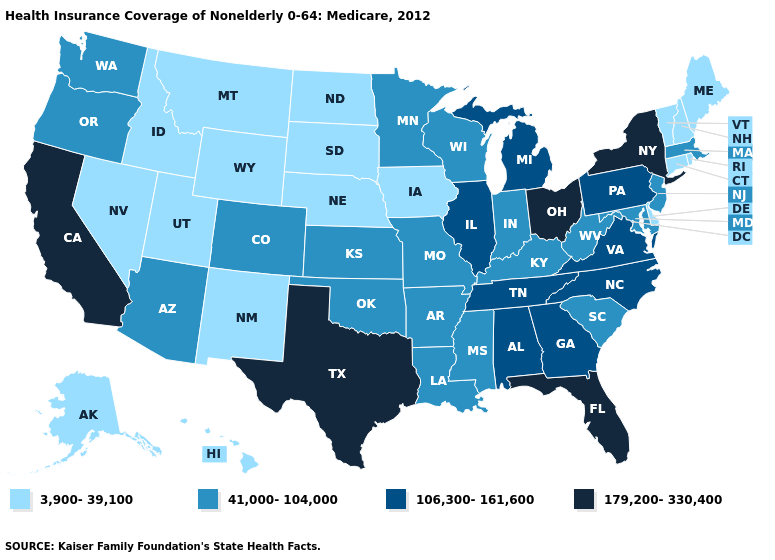What is the value of Alabama?
Answer briefly. 106,300-161,600. Name the states that have a value in the range 3,900-39,100?
Concise answer only. Alaska, Connecticut, Delaware, Hawaii, Idaho, Iowa, Maine, Montana, Nebraska, Nevada, New Hampshire, New Mexico, North Dakota, Rhode Island, South Dakota, Utah, Vermont, Wyoming. What is the highest value in states that border New York?
Answer briefly. 106,300-161,600. Which states have the lowest value in the West?
Concise answer only. Alaska, Hawaii, Idaho, Montana, Nevada, New Mexico, Utah, Wyoming. Is the legend a continuous bar?
Keep it brief. No. Does Ohio have the highest value in the MidWest?
Give a very brief answer. Yes. Does California have the highest value in the USA?
Be succinct. Yes. How many symbols are there in the legend?
Give a very brief answer. 4. What is the value of Texas?
Be succinct. 179,200-330,400. Name the states that have a value in the range 106,300-161,600?
Answer briefly. Alabama, Georgia, Illinois, Michigan, North Carolina, Pennsylvania, Tennessee, Virginia. Among the states that border Kansas , does Oklahoma have the lowest value?
Keep it brief. No. How many symbols are there in the legend?
Quick response, please. 4. Among the states that border Virginia , which have the lowest value?
Keep it brief. Kentucky, Maryland, West Virginia. Which states have the highest value in the USA?
Write a very short answer. California, Florida, New York, Ohio, Texas. What is the value of Alaska?
Give a very brief answer. 3,900-39,100. 